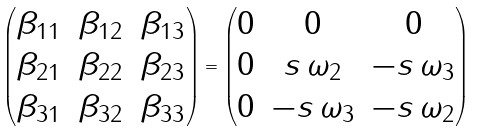Convert formula to latex. <formula><loc_0><loc_0><loc_500><loc_500>\begin{pmatrix} \beta _ { 1 1 } & \beta _ { 1 2 } & \beta _ { 1 3 } \\ \beta _ { 2 1 } & \beta _ { 2 2 } & \beta _ { 2 3 } \\ \beta _ { 3 1 } & \beta _ { 3 2 } & \beta _ { 3 3 } \end{pmatrix} = \begin{pmatrix} 0 & 0 & 0 \\ 0 & s \, \omega _ { 2 } & - s \, \omega _ { 3 } \\ 0 & - s \, \omega _ { 3 } & - s \, \omega _ { 2 } \end{pmatrix}</formula> 